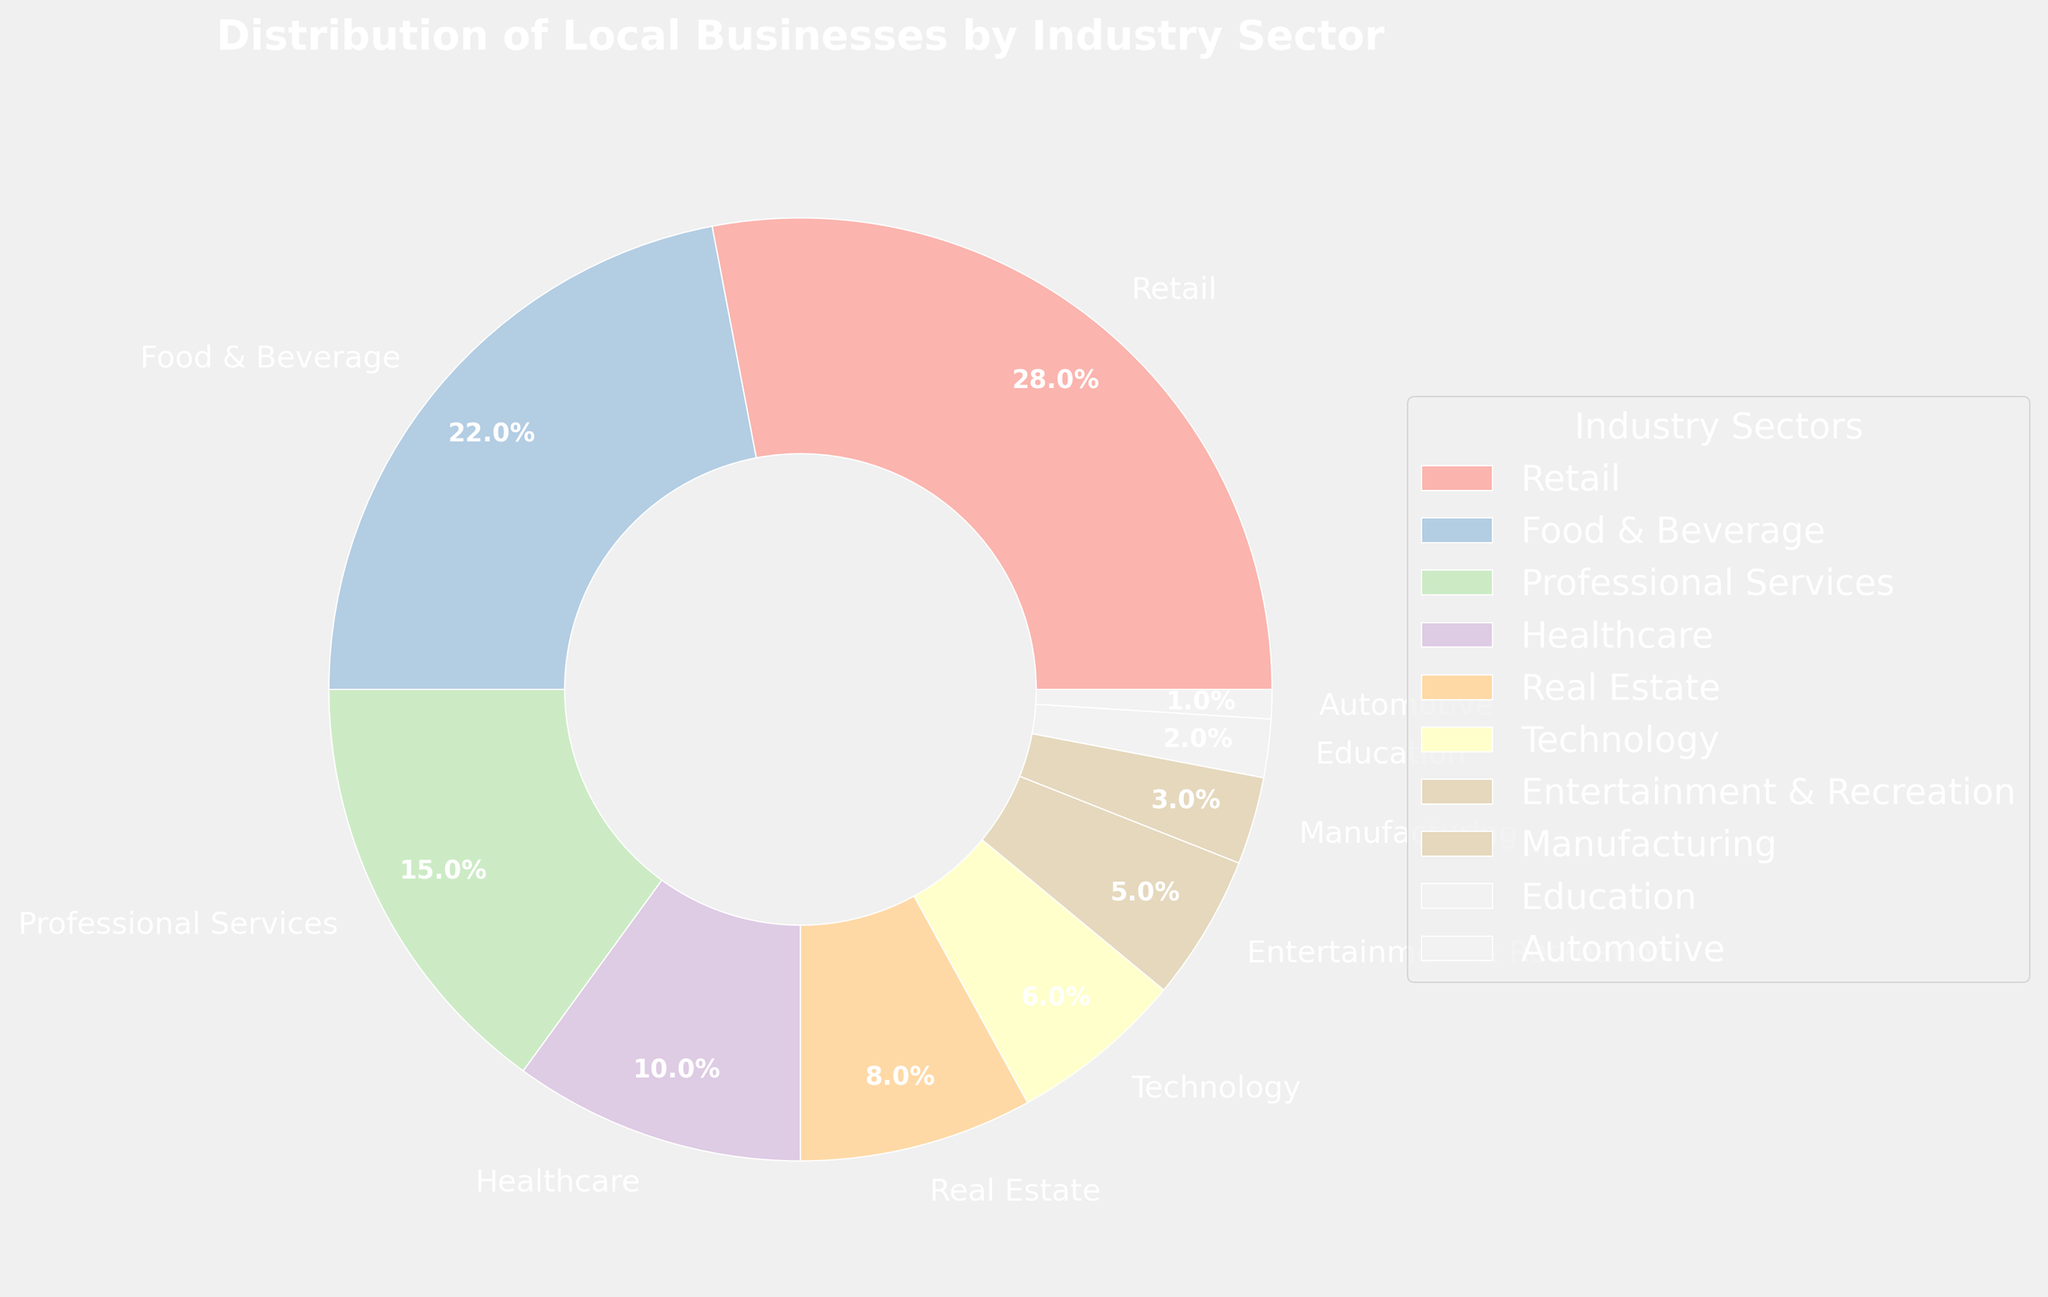Which industry sector has the highest percentage of local businesses? Referring to the pie chart, the sector with the largest slice is Retail. This indicates that Retail has the highest percentage.
Answer: Retail How much larger is the percentage of Retail compared to Technology? The percentage for Retail is 28%, and for Technology, it is 6%. To find how much larger Retail is compared to Technology, subtract Technology from Retail: 28% - 6% = 22%.
Answer: 22% What is the combined percentage of Food & Beverage and Healthcare sectors? The percentage for Food & Beverage is 22%, and for Healthcare, it is 10%. Adding these together gives 22% + 10% = 32%.
Answer: 32% Which sector has the smallest percentage, and by how much is it smaller than Manufacturing? The Automotive sector has the smallest percentage at 1%. The Manufacturing sector has a percentage of 3%. To find the difference, subtract Automotive from Manufacturing: 3% - 1% = 2%.
Answer: Automotive, 2% Are there any sectors with equal percentages? Referring to the pie chart, we need to check each sector's percentage. None of the sectors share the same percentage as all are distinct.
Answer: No What percentage of local businesses is represented by the top three sectors combined? The top three sectors are Retail (28%), Food & Beverage (22%), and Professional Services (15%). Adding these together gives 28% + 22% + 15% = 65%.
Answer: 65% How many sectors have a percentage lower than Professional Services? First, identify the percentage of Professional Services, which is 15%. Then, count the sectors with a lower percentage: Healthcare (10%), Real Estate (8%), Technology (6%), Entertainment & Recreation (5%), Manufacturing (3%), Education (2%), Automotive (1%). There are 7 such sectors.
Answer: 7 Is the percentage of Healthcare sector larger than the sum of Manufacturing and Automotive sectors? The percentage for Healthcare is 10%, and the sum of Manufacturing (3%) and Automotive (1%) is 3% + 1% = 4%. Since 10% is greater than 4%, Healthcare is larger.
Answer: Yes What's the average percentage of the sectors listed in the pie chart? Summing all percentages: 28% + 22% + 15% + 10% + 8% + 6% + 5% + 3% + 2% + 1% = 100%. There are 10 sectors. The average percentage is the total sum divided by the number of sectors: 100% / 10 = 10%.
Answer: 10% 